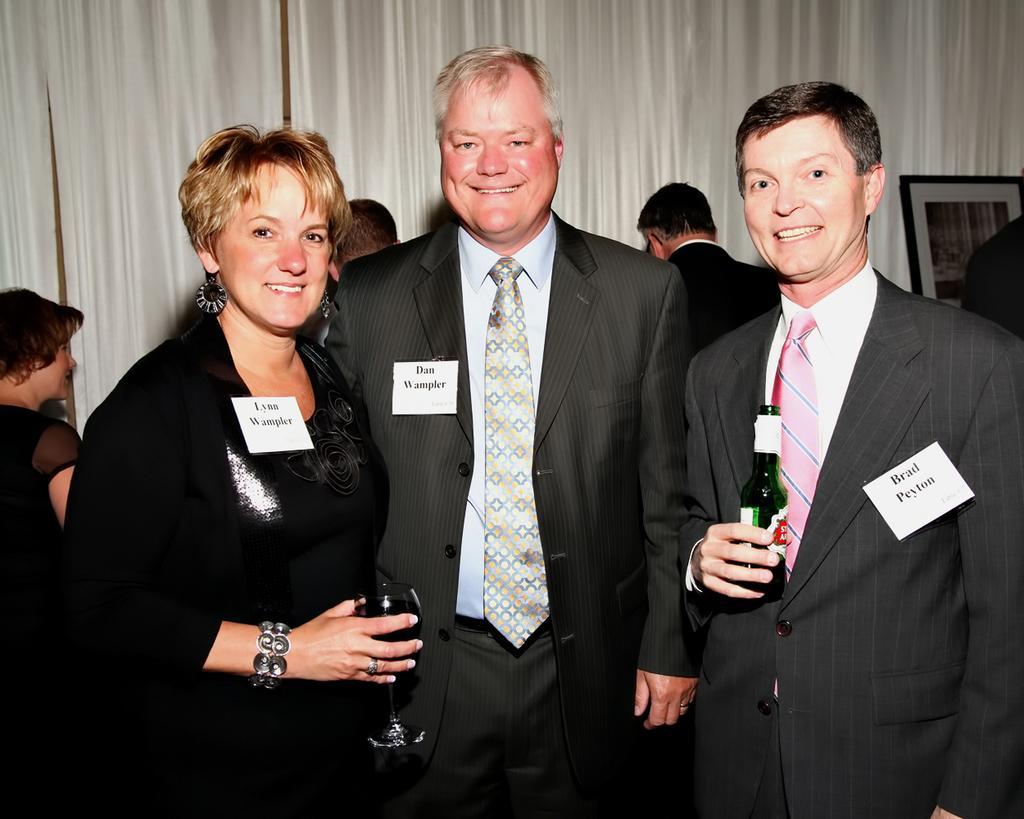In one or two sentences, can you explain what this image depicts? In this picture we can see a group of people standing and a man is holding a bottle and the woman is holding a wine glass. Behind the people there are white curtains and a photo frame. 